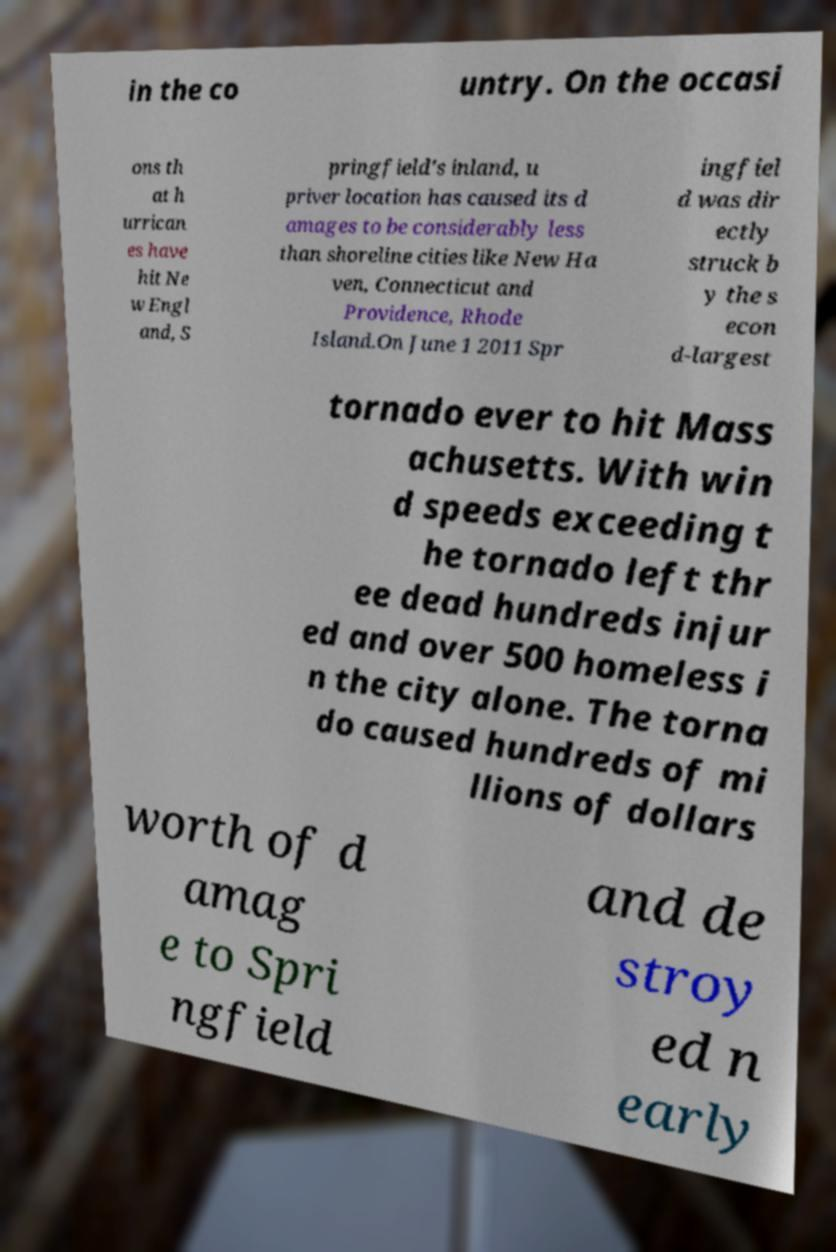There's text embedded in this image that I need extracted. Can you transcribe it verbatim? in the co untry. On the occasi ons th at h urrican es have hit Ne w Engl and, S pringfield's inland, u priver location has caused its d amages to be considerably less than shoreline cities like New Ha ven, Connecticut and Providence, Rhode Island.On June 1 2011 Spr ingfiel d was dir ectly struck b y the s econ d-largest tornado ever to hit Mass achusetts. With win d speeds exceeding t he tornado left thr ee dead hundreds injur ed and over 500 homeless i n the city alone. The torna do caused hundreds of mi llions of dollars worth of d amag e to Spri ngfield and de stroy ed n early 